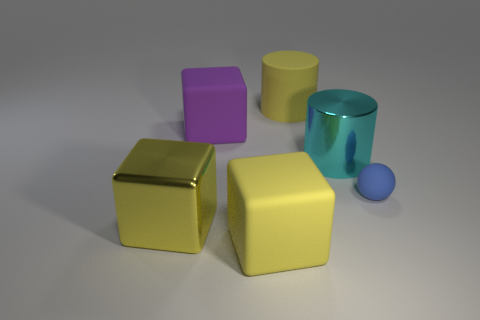How many other things are there of the same color as the big shiny block?
Provide a short and direct response. 2. Is the size of the cyan metallic cylinder the same as the yellow matte thing behind the large metal block?
Give a very brief answer. Yes. There is a object behind the large rubber block that is behind the shiny cube; what is its size?
Your answer should be compact. Large. There is another thing that is the same shape as the large cyan metallic thing; what color is it?
Your answer should be compact. Yellow. Does the purple block have the same size as the blue matte ball?
Keep it short and to the point. No. Is the number of yellow metallic blocks that are in front of the sphere the same as the number of large rubber objects?
Keep it short and to the point. No. There is a big cylinder in front of the big matte cylinder; is there a big cyan metallic thing behind it?
Make the answer very short. No. There is a yellow matte thing behind the big matte block that is behind the large shiny thing that is in front of the rubber sphere; what is its size?
Make the answer very short. Large. The large yellow thing that is in front of the large yellow metallic object in front of the small blue ball is made of what material?
Offer a very short reply. Rubber. Are there any yellow rubber things that have the same shape as the big purple matte object?
Offer a terse response. Yes. 